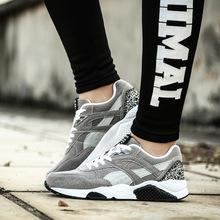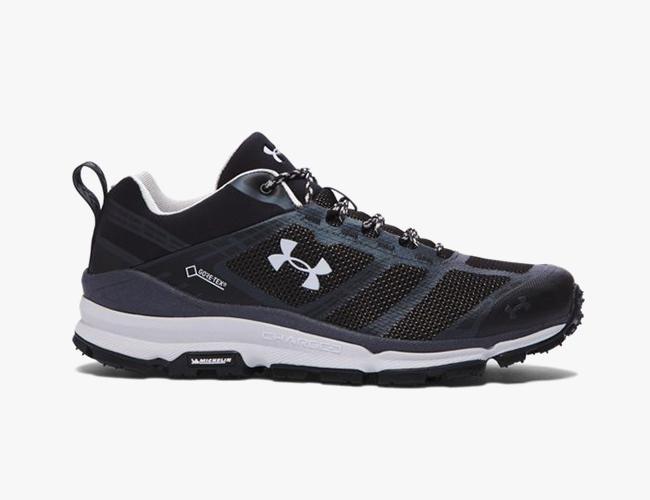The first image is the image on the left, the second image is the image on the right. Evaluate the accuracy of this statement regarding the images: "In one image there are two people running outside with snow on the ground.". Is it true? Answer yes or no. No. The first image is the image on the left, the second image is the image on the right. Analyze the images presented: Is the assertion "there is humans in the right side image" valid? Answer yes or no. No. 